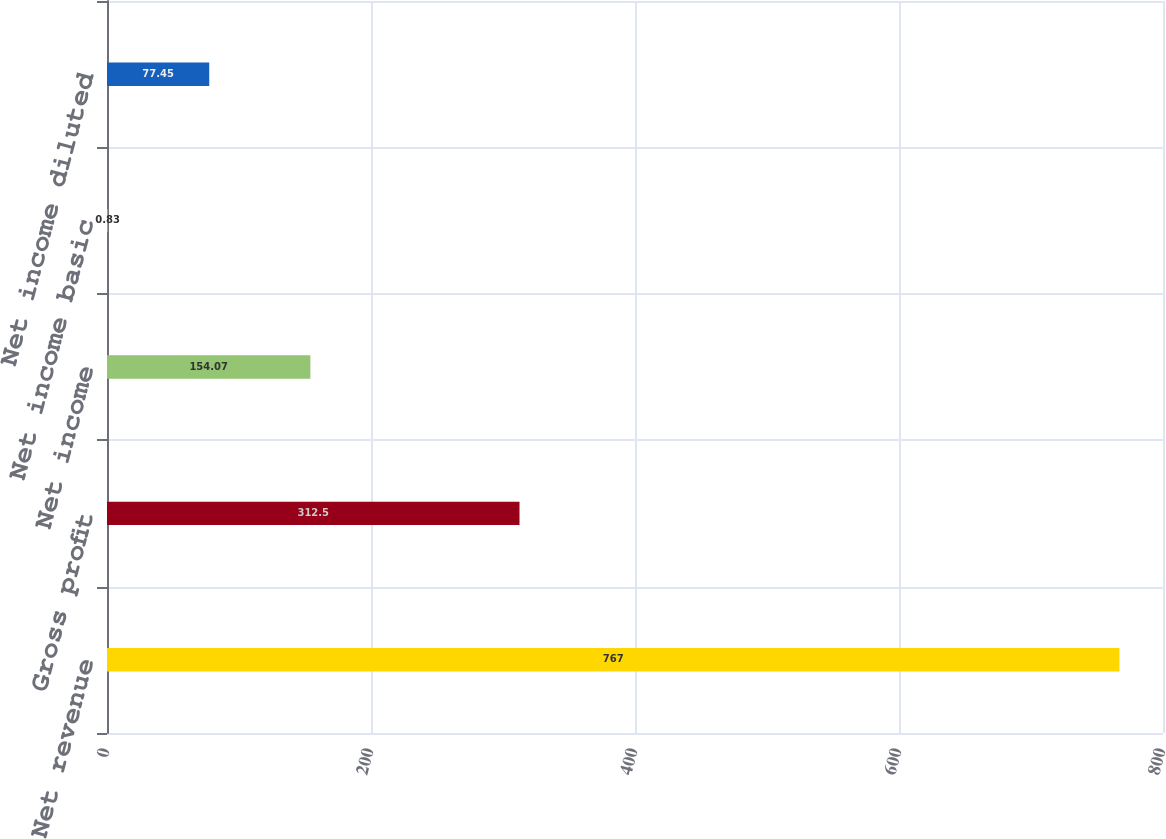<chart> <loc_0><loc_0><loc_500><loc_500><bar_chart><fcel>Net revenue<fcel>Gross profit<fcel>Net income<fcel>Net income basic<fcel>Net income diluted<nl><fcel>767<fcel>312.5<fcel>154.07<fcel>0.83<fcel>77.45<nl></chart> 